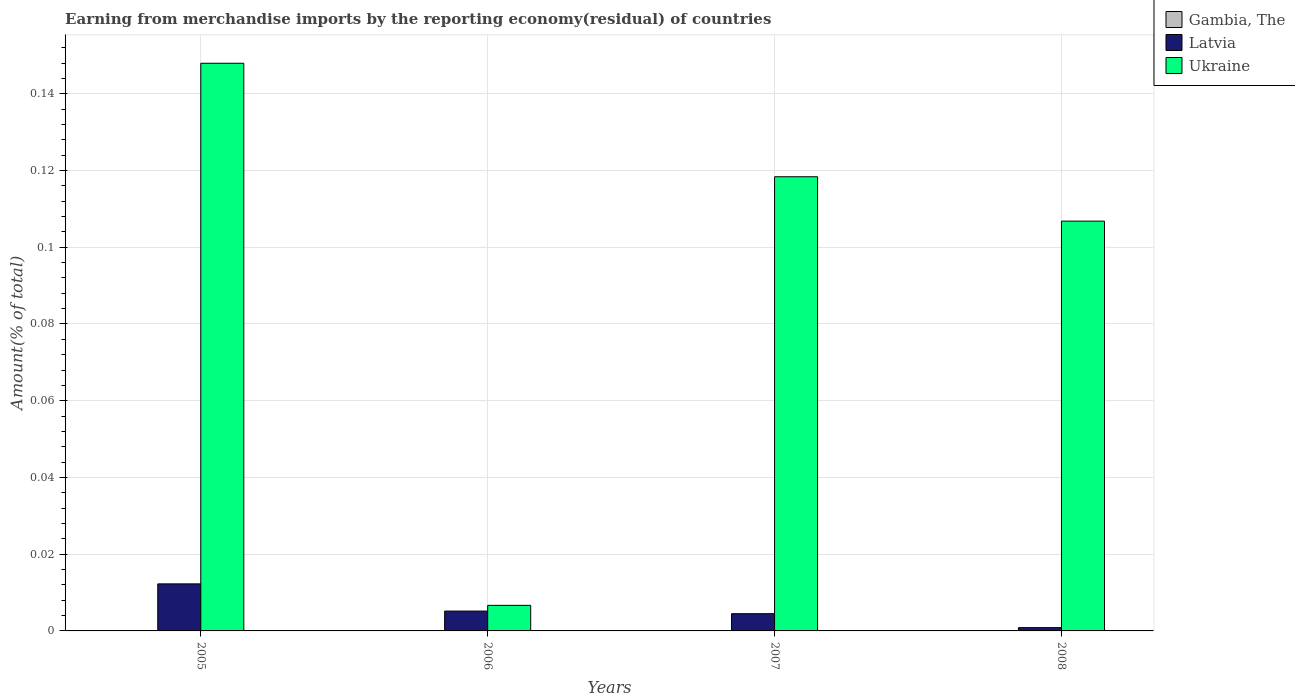How many groups of bars are there?
Provide a short and direct response. 4. How many bars are there on the 1st tick from the left?
Offer a very short reply. 3. How many bars are there on the 3rd tick from the right?
Provide a succinct answer. 3. What is the label of the 3rd group of bars from the left?
Your answer should be very brief. 2007. What is the percentage of amount earned from merchandise imports in Gambia, The in 2005?
Make the answer very short. 6.71216324680724e-9. Across all years, what is the maximum percentage of amount earned from merchandise imports in Ukraine?
Your answer should be compact. 0.15. Across all years, what is the minimum percentage of amount earned from merchandise imports in Ukraine?
Offer a terse response. 0.01. In which year was the percentage of amount earned from merchandise imports in Ukraine maximum?
Give a very brief answer. 2005. What is the total percentage of amount earned from merchandise imports in Ukraine in the graph?
Offer a very short reply. 0.38. What is the difference between the percentage of amount earned from merchandise imports in Ukraine in 2006 and that in 2007?
Ensure brevity in your answer.  -0.11. What is the difference between the percentage of amount earned from merchandise imports in Ukraine in 2008 and the percentage of amount earned from merchandise imports in Latvia in 2006?
Provide a succinct answer. 0.1. What is the average percentage of amount earned from merchandise imports in Gambia, The per year?
Provide a succinct answer. 3.3967328650151523e-9. In the year 2005, what is the difference between the percentage of amount earned from merchandise imports in Ukraine and percentage of amount earned from merchandise imports in Latvia?
Make the answer very short. 0.14. In how many years, is the percentage of amount earned from merchandise imports in Latvia greater than 0.12 %?
Your answer should be compact. 0. What is the ratio of the percentage of amount earned from merchandise imports in Latvia in 2007 to that in 2008?
Give a very brief answer. 5.24. Is the percentage of amount earned from merchandise imports in Latvia in 2005 less than that in 2006?
Your answer should be very brief. No. What is the difference between the highest and the second highest percentage of amount earned from merchandise imports in Latvia?
Give a very brief answer. 0.01. What is the difference between the highest and the lowest percentage of amount earned from merchandise imports in Latvia?
Provide a short and direct response. 0.01. Is the sum of the percentage of amount earned from merchandise imports in Latvia in 2005 and 2006 greater than the maximum percentage of amount earned from merchandise imports in Ukraine across all years?
Ensure brevity in your answer.  No. Is it the case that in every year, the sum of the percentage of amount earned from merchandise imports in Gambia, The and percentage of amount earned from merchandise imports in Ukraine is greater than the percentage of amount earned from merchandise imports in Latvia?
Offer a very short reply. Yes. How many bars are there?
Make the answer very short. 11. How many years are there in the graph?
Keep it short and to the point. 4. What is the difference between two consecutive major ticks on the Y-axis?
Offer a very short reply. 0.02. Are the values on the major ticks of Y-axis written in scientific E-notation?
Your response must be concise. No. Does the graph contain grids?
Keep it short and to the point. Yes. How many legend labels are there?
Make the answer very short. 3. What is the title of the graph?
Offer a terse response. Earning from merchandise imports by the reporting economy(residual) of countries. Does "Malta" appear as one of the legend labels in the graph?
Keep it short and to the point. No. What is the label or title of the X-axis?
Keep it short and to the point. Years. What is the label or title of the Y-axis?
Give a very brief answer. Amount(% of total). What is the Amount(% of total) of Gambia, The in 2005?
Your answer should be very brief. 6.71216324680724e-9. What is the Amount(% of total) in Latvia in 2005?
Ensure brevity in your answer.  0.01. What is the Amount(% of total) in Ukraine in 2005?
Your response must be concise. 0.15. What is the Amount(% of total) in Gambia, The in 2006?
Ensure brevity in your answer.  3.96299872620078e-9. What is the Amount(% of total) in Latvia in 2006?
Your answer should be compact. 0.01. What is the Amount(% of total) in Ukraine in 2006?
Offer a very short reply. 0.01. What is the Amount(% of total) of Gambia, The in 2007?
Keep it short and to the point. 0. What is the Amount(% of total) in Latvia in 2007?
Your response must be concise. 0. What is the Amount(% of total) of Ukraine in 2007?
Ensure brevity in your answer.  0.12. What is the Amount(% of total) of Gambia, The in 2008?
Offer a very short reply. 2.91176948705259e-9. What is the Amount(% of total) in Latvia in 2008?
Provide a succinct answer. 0. What is the Amount(% of total) in Ukraine in 2008?
Your response must be concise. 0.11. Across all years, what is the maximum Amount(% of total) of Gambia, The?
Offer a terse response. 6.71216324680724e-9. Across all years, what is the maximum Amount(% of total) in Latvia?
Your answer should be compact. 0.01. Across all years, what is the maximum Amount(% of total) in Ukraine?
Ensure brevity in your answer.  0.15. Across all years, what is the minimum Amount(% of total) of Gambia, The?
Provide a short and direct response. 0. Across all years, what is the minimum Amount(% of total) of Latvia?
Give a very brief answer. 0. Across all years, what is the minimum Amount(% of total) in Ukraine?
Offer a very short reply. 0.01. What is the total Amount(% of total) of Gambia, The in the graph?
Give a very brief answer. 0. What is the total Amount(% of total) in Latvia in the graph?
Provide a short and direct response. 0.02. What is the total Amount(% of total) of Ukraine in the graph?
Give a very brief answer. 0.38. What is the difference between the Amount(% of total) in Latvia in 2005 and that in 2006?
Ensure brevity in your answer.  0.01. What is the difference between the Amount(% of total) in Ukraine in 2005 and that in 2006?
Keep it short and to the point. 0.14. What is the difference between the Amount(% of total) in Latvia in 2005 and that in 2007?
Provide a short and direct response. 0.01. What is the difference between the Amount(% of total) in Ukraine in 2005 and that in 2007?
Make the answer very short. 0.03. What is the difference between the Amount(% of total) in Gambia, The in 2005 and that in 2008?
Make the answer very short. 0. What is the difference between the Amount(% of total) in Latvia in 2005 and that in 2008?
Give a very brief answer. 0.01. What is the difference between the Amount(% of total) in Ukraine in 2005 and that in 2008?
Give a very brief answer. 0.04. What is the difference between the Amount(% of total) of Latvia in 2006 and that in 2007?
Provide a short and direct response. 0. What is the difference between the Amount(% of total) in Ukraine in 2006 and that in 2007?
Offer a very short reply. -0.11. What is the difference between the Amount(% of total) of Gambia, The in 2006 and that in 2008?
Offer a very short reply. 0. What is the difference between the Amount(% of total) in Latvia in 2006 and that in 2008?
Make the answer very short. 0. What is the difference between the Amount(% of total) in Ukraine in 2006 and that in 2008?
Your answer should be very brief. -0.1. What is the difference between the Amount(% of total) of Latvia in 2007 and that in 2008?
Make the answer very short. 0. What is the difference between the Amount(% of total) in Ukraine in 2007 and that in 2008?
Your response must be concise. 0.01. What is the difference between the Amount(% of total) in Gambia, The in 2005 and the Amount(% of total) in Latvia in 2006?
Provide a short and direct response. -0.01. What is the difference between the Amount(% of total) of Gambia, The in 2005 and the Amount(% of total) of Ukraine in 2006?
Your answer should be compact. -0.01. What is the difference between the Amount(% of total) of Latvia in 2005 and the Amount(% of total) of Ukraine in 2006?
Provide a succinct answer. 0.01. What is the difference between the Amount(% of total) in Gambia, The in 2005 and the Amount(% of total) in Latvia in 2007?
Provide a short and direct response. -0. What is the difference between the Amount(% of total) in Gambia, The in 2005 and the Amount(% of total) in Ukraine in 2007?
Provide a short and direct response. -0.12. What is the difference between the Amount(% of total) of Latvia in 2005 and the Amount(% of total) of Ukraine in 2007?
Your answer should be compact. -0.11. What is the difference between the Amount(% of total) in Gambia, The in 2005 and the Amount(% of total) in Latvia in 2008?
Your answer should be compact. -0. What is the difference between the Amount(% of total) of Gambia, The in 2005 and the Amount(% of total) of Ukraine in 2008?
Offer a terse response. -0.11. What is the difference between the Amount(% of total) in Latvia in 2005 and the Amount(% of total) in Ukraine in 2008?
Provide a succinct answer. -0.09. What is the difference between the Amount(% of total) of Gambia, The in 2006 and the Amount(% of total) of Latvia in 2007?
Give a very brief answer. -0. What is the difference between the Amount(% of total) in Gambia, The in 2006 and the Amount(% of total) in Ukraine in 2007?
Keep it short and to the point. -0.12. What is the difference between the Amount(% of total) in Latvia in 2006 and the Amount(% of total) in Ukraine in 2007?
Give a very brief answer. -0.11. What is the difference between the Amount(% of total) of Gambia, The in 2006 and the Amount(% of total) of Latvia in 2008?
Provide a succinct answer. -0. What is the difference between the Amount(% of total) in Gambia, The in 2006 and the Amount(% of total) in Ukraine in 2008?
Make the answer very short. -0.11. What is the difference between the Amount(% of total) in Latvia in 2006 and the Amount(% of total) in Ukraine in 2008?
Make the answer very short. -0.1. What is the difference between the Amount(% of total) in Latvia in 2007 and the Amount(% of total) in Ukraine in 2008?
Ensure brevity in your answer.  -0.1. What is the average Amount(% of total) in Latvia per year?
Your answer should be compact. 0.01. What is the average Amount(% of total) in Ukraine per year?
Provide a short and direct response. 0.1. In the year 2005, what is the difference between the Amount(% of total) in Gambia, The and Amount(% of total) in Latvia?
Ensure brevity in your answer.  -0.01. In the year 2005, what is the difference between the Amount(% of total) of Gambia, The and Amount(% of total) of Ukraine?
Your answer should be compact. -0.15. In the year 2005, what is the difference between the Amount(% of total) in Latvia and Amount(% of total) in Ukraine?
Provide a short and direct response. -0.14. In the year 2006, what is the difference between the Amount(% of total) of Gambia, The and Amount(% of total) of Latvia?
Your answer should be compact. -0.01. In the year 2006, what is the difference between the Amount(% of total) of Gambia, The and Amount(% of total) of Ukraine?
Offer a terse response. -0.01. In the year 2006, what is the difference between the Amount(% of total) of Latvia and Amount(% of total) of Ukraine?
Ensure brevity in your answer.  -0. In the year 2007, what is the difference between the Amount(% of total) of Latvia and Amount(% of total) of Ukraine?
Your answer should be compact. -0.11. In the year 2008, what is the difference between the Amount(% of total) in Gambia, The and Amount(% of total) in Latvia?
Ensure brevity in your answer.  -0. In the year 2008, what is the difference between the Amount(% of total) in Gambia, The and Amount(% of total) in Ukraine?
Offer a very short reply. -0.11. In the year 2008, what is the difference between the Amount(% of total) of Latvia and Amount(% of total) of Ukraine?
Keep it short and to the point. -0.11. What is the ratio of the Amount(% of total) in Gambia, The in 2005 to that in 2006?
Ensure brevity in your answer.  1.69. What is the ratio of the Amount(% of total) of Latvia in 2005 to that in 2006?
Your answer should be very brief. 2.37. What is the ratio of the Amount(% of total) of Ukraine in 2005 to that in 2006?
Offer a very short reply. 22.2. What is the ratio of the Amount(% of total) in Latvia in 2005 to that in 2007?
Provide a succinct answer. 2.73. What is the ratio of the Amount(% of total) in Ukraine in 2005 to that in 2007?
Keep it short and to the point. 1.25. What is the ratio of the Amount(% of total) of Gambia, The in 2005 to that in 2008?
Provide a short and direct response. 2.31. What is the ratio of the Amount(% of total) in Latvia in 2005 to that in 2008?
Offer a very short reply. 14.3. What is the ratio of the Amount(% of total) in Ukraine in 2005 to that in 2008?
Ensure brevity in your answer.  1.39. What is the ratio of the Amount(% of total) of Latvia in 2006 to that in 2007?
Your response must be concise. 1.15. What is the ratio of the Amount(% of total) of Ukraine in 2006 to that in 2007?
Ensure brevity in your answer.  0.06. What is the ratio of the Amount(% of total) in Gambia, The in 2006 to that in 2008?
Your response must be concise. 1.36. What is the ratio of the Amount(% of total) of Latvia in 2006 to that in 2008?
Your answer should be compact. 6.03. What is the ratio of the Amount(% of total) of Ukraine in 2006 to that in 2008?
Provide a short and direct response. 0.06. What is the ratio of the Amount(% of total) of Latvia in 2007 to that in 2008?
Offer a very short reply. 5.24. What is the ratio of the Amount(% of total) of Ukraine in 2007 to that in 2008?
Offer a terse response. 1.11. What is the difference between the highest and the second highest Amount(% of total) of Latvia?
Offer a very short reply. 0.01. What is the difference between the highest and the second highest Amount(% of total) of Ukraine?
Provide a short and direct response. 0.03. What is the difference between the highest and the lowest Amount(% of total) in Latvia?
Your response must be concise. 0.01. What is the difference between the highest and the lowest Amount(% of total) in Ukraine?
Ensure brevity in your answer.  0.14. 